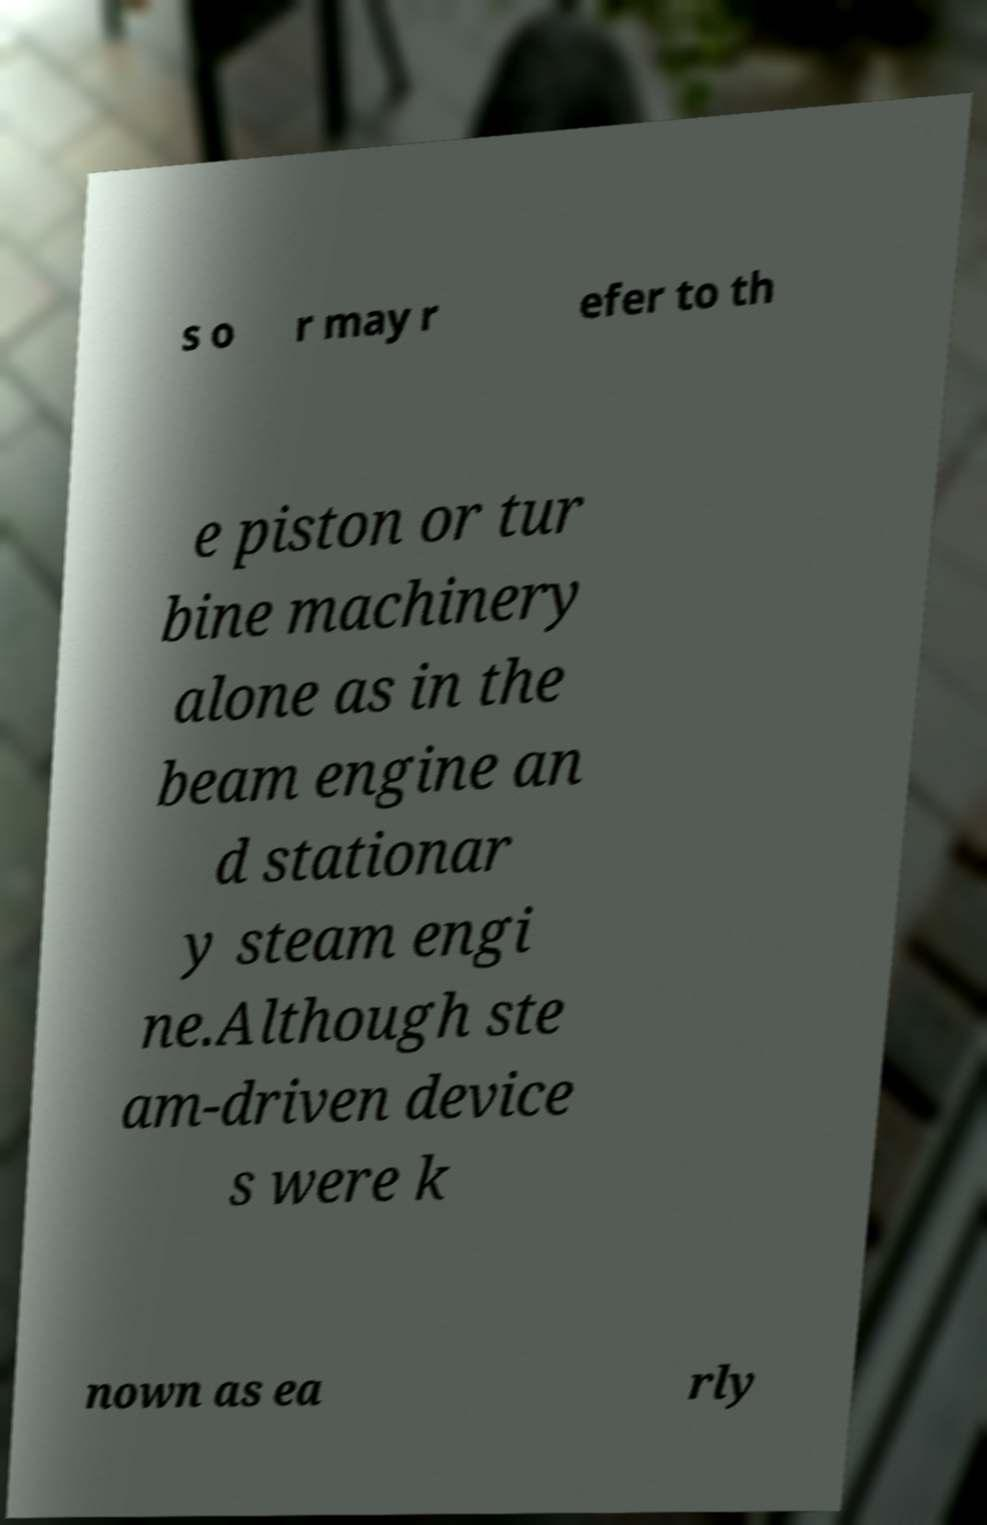Can you read and provide the text displayed in the image?This photo seems to have some interesting text. Can you extract and type it out for me? s o r may r efer to th e piston or tur bine machinery alone as in the beam engine an d stationar y steam engi ne.Although ste am-driven device s were k nown as ea rly 